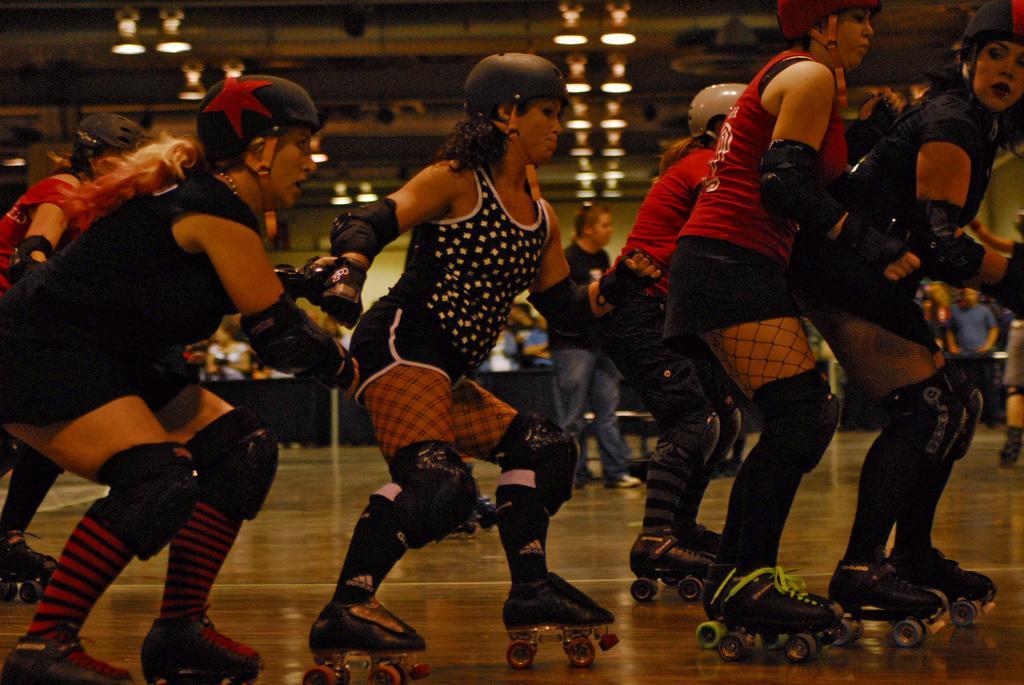Describe this image in one or two sentences. In this picture, we see women are skating. In the background, we see a wall in green color and at the top of the picture, we see the ceiling of the room. 